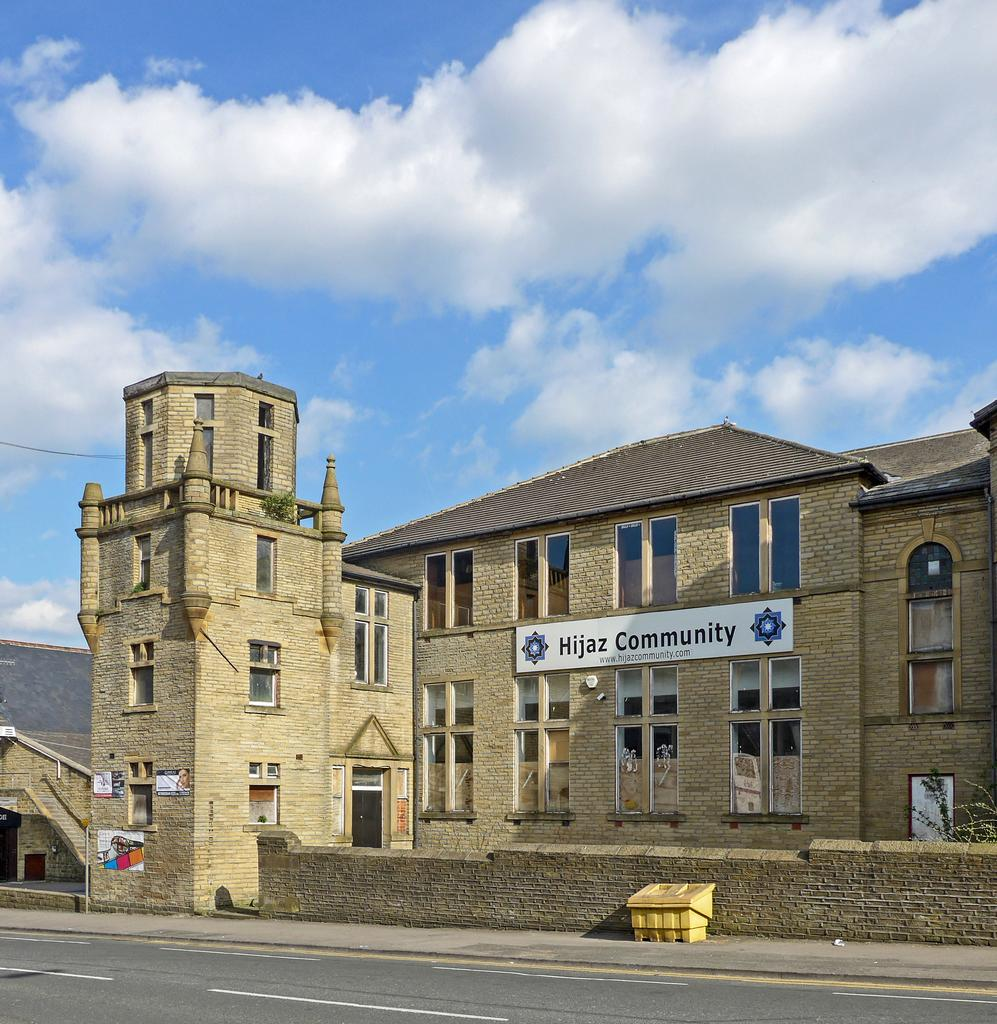What is visible in the center of the image? The sky is visible in the center of the image. What can be seen in the sky? Clouds are present in the image. What type of structures are in the image? There are buildings in the image. What part of the buildings can be seen? Windows are visible in the image. What is written or displayed on a board in the image? There is a board with text in the image. Can you describe any other objects in the image? There are a few other objects in the image. What type of cord is connected to the machine in the image? There is no machine or cord present in the image. What color is the collar on the dog in the image? There is no dog or collar present in the image. 